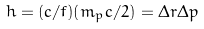Convert formula to latex. <formula><loc_0><loc_0><loc_500><loc_500>h = ( c / f ) ( m _ { p } c / 2 ) = \Delta r \Delta p</formula> 